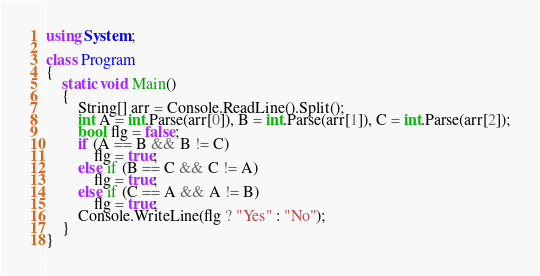Convert code to text. <code><loc_0><loc_0><loc_500><loc_500><_C#_>using System;

class Program
{
    static void Main()
    {
        String[] arr = Console.ReadLine().Split();
        int A = int.Parse(arr[0]), B = int.Parse(arr[1]), C = int.Parse(arr[2]);
        bool flg = false;
        if (A == B && B != C)
            flg = true;
        else if (B == C && C != A)
            flg = true;
        else if (C == A && A != B)
            flg = true;
        Console.WriteLine(flg ? "Yes" : "No");
    }
}</code> 